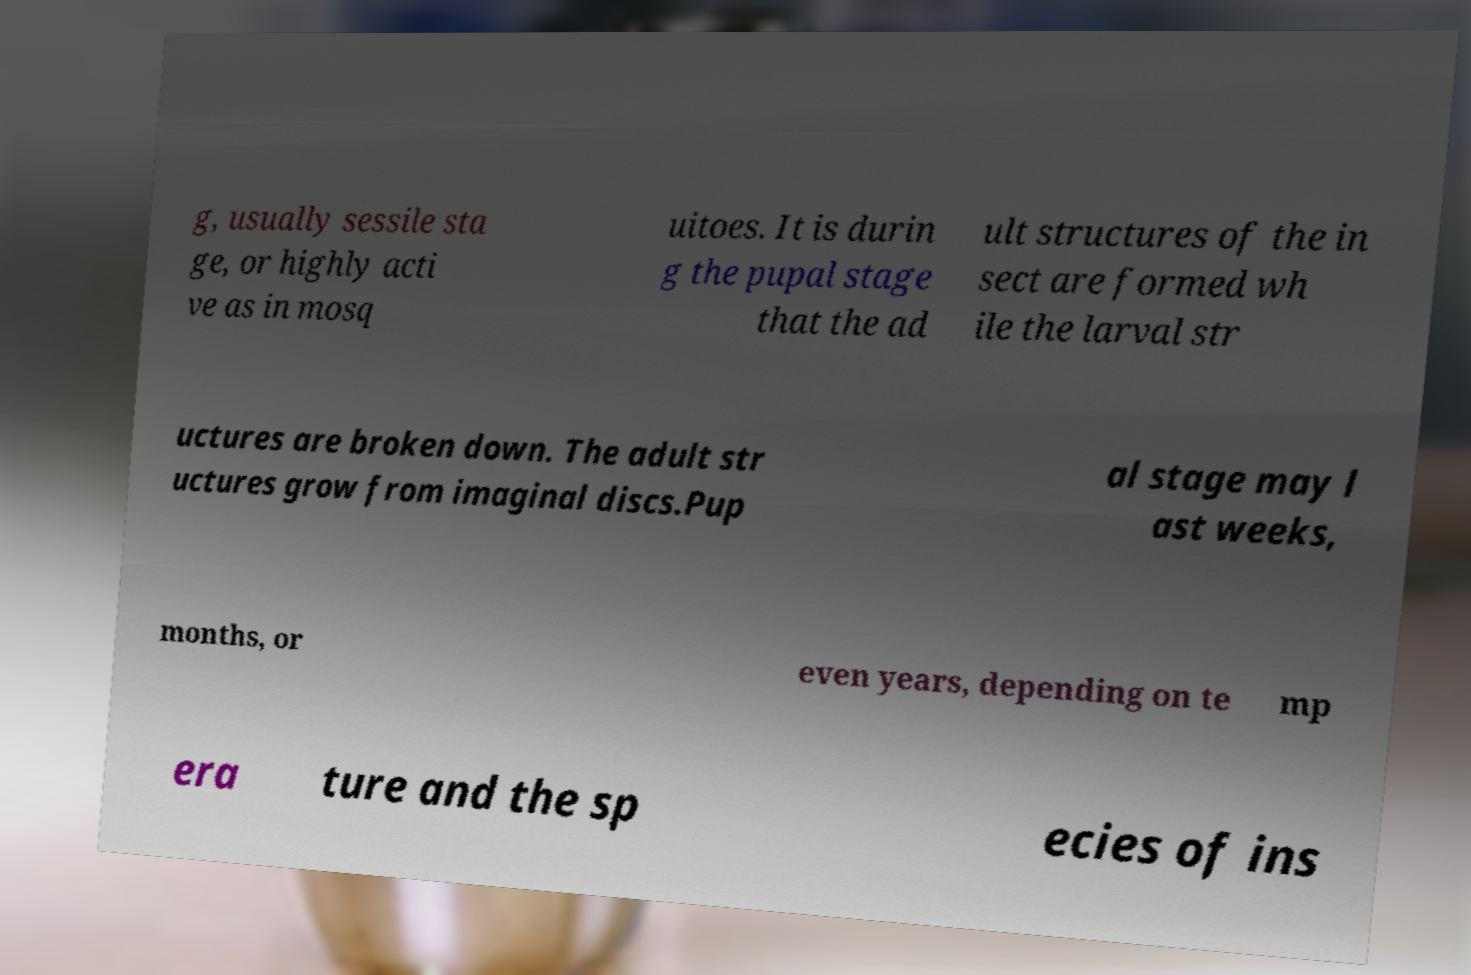For documentation purposes, I need the text within this image transcribed. Could you provide that? g, usually sessile sta ge, or highly acti ve as in mosq uitoes. It is durin g the pupal stage that the ad ult structures of the in sect are formed wh ile the larval str uctures are broken down. The adult str uctures grow from imaginal discs.Pup al stage may l ast weeks, months, or even years, depending on te mp era ture and the sp ecies of ins 